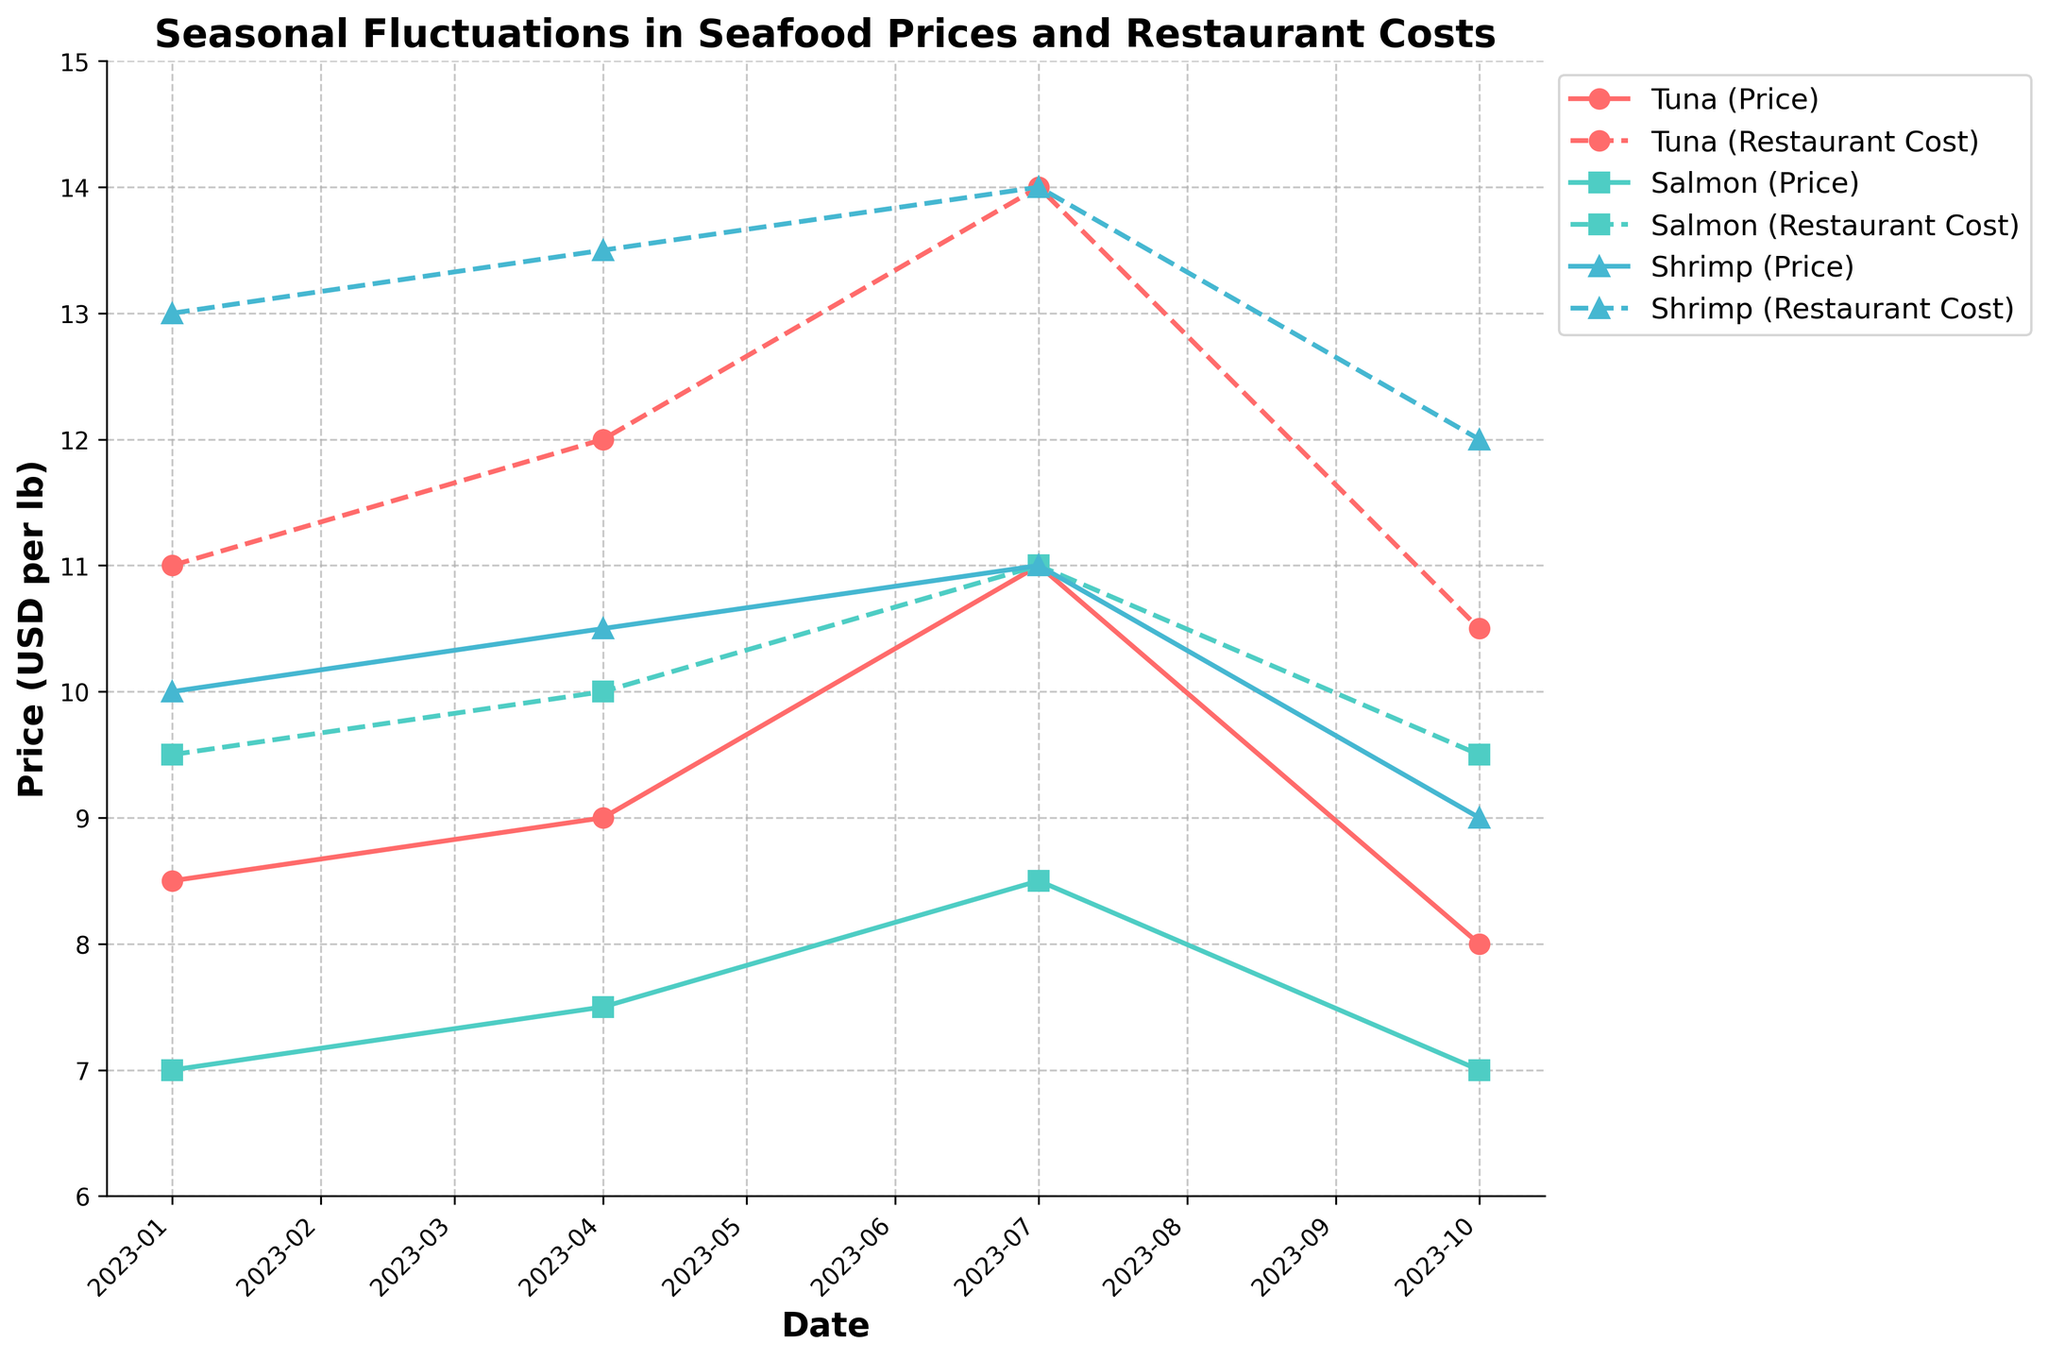What's the title of the graph? The title of the graph is usually displayed at the top of the figure. In this case, based on the code provided, the title is "Seasonal Fluctuations in Seafood Prices and Restaurant Costs".
Answer: Seasonal Fluctuations in Seafood Prices and Restaurant Costs How many different types of seafood are shown in the plot? The plot shows lines for different types of seafood. By looking at the legend or examining the different colored lines, one can see there are three types of seafood: Tuna, Salmon, and Shrimp.
Answer: Three What color is used to represent Tuna's price and restaurant cost? By examining the legend and the colored lines in the plot, Tuna is represented using a red color for both its price and restaurant cost.
Answer: Red In which month does Salmon have the highest price? To find this, look at the points corresponding to Salmon's price over the time axis. The highest price for Salmon, based on the plot, is reached in July.
Answer: July Which seafood had the highest price in July? To determine this, compare the prices for Tuna, Salmon, and Shrimp in July. The plot shows that Tuna and Shrimp both have a price of 11.00 USD per lb, which are the highest.
Answer: Tuna and Shrimp What is the difference between Tuna's price and its restaurant cost in October? In October, Tuna's price is 8.00 USD per lb and its restaurant cost is 10.50 USD per lb. The difference is calculated as 10.50 - 8.00.
Answer: 2.50 Which seafood's restaurant cost has the smallest increase from January to April? To find this, examine the restaurant costs for all seafood types in both January and April, then calculate their differences: Tuna (12.00-11.00=1.00), Salmon (10.00-9.50=0.50), and Shrimp (13.50-13.00=0.50). Both Salmon and Shrimp have the smallest increase.
Answer: Salmon and Shrimp When did Shrimp have the lowest restaurant cost? Looking at the restaurant cost trends for Shrimp over the months, the lowest restaurant cost is observed in January.
Answer: January Did Salmon's price ever exceed Tuna's price? To determine this, compare the prices of both Salmon and Tuna on the plot across all time periods. Salmon's prices never exceed Tuna's prices at any point in the plot.
Answer: No 